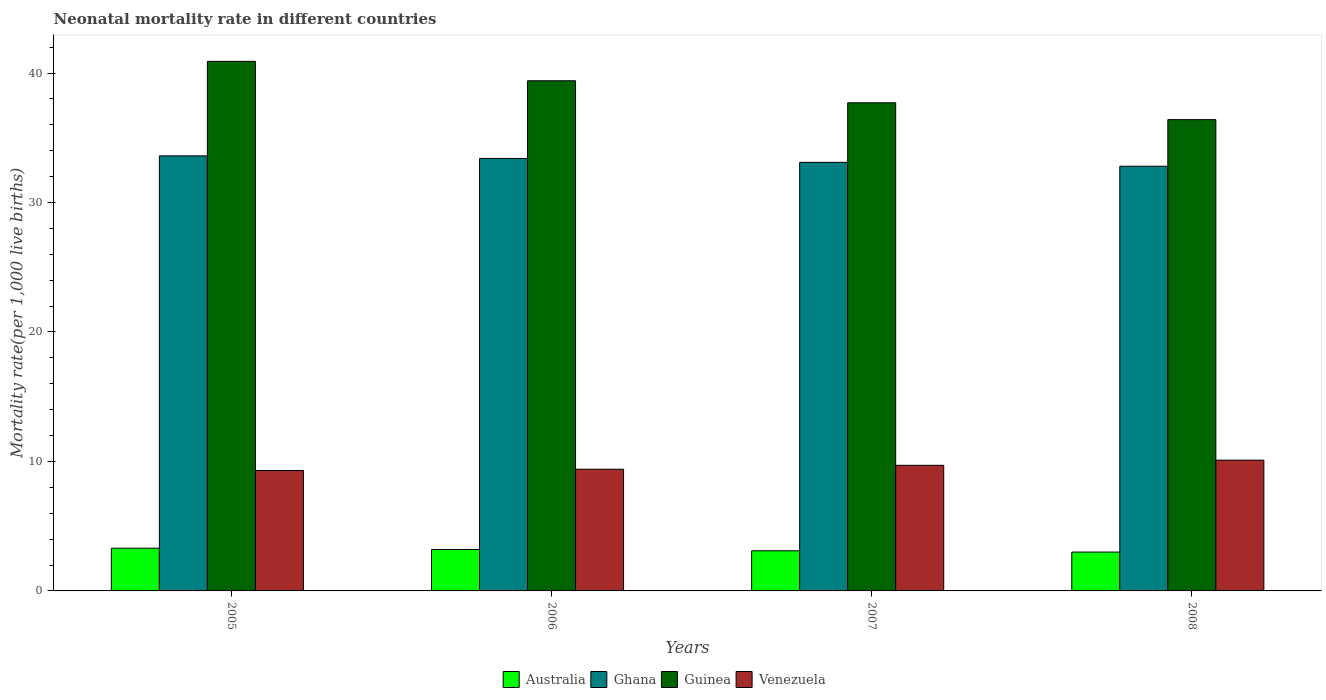Are the number of bars per tick equal to the number of legend labels?
Ensure brevity in your answer.  Yes. Are the number of bars on each tick of the X-axis equal?
Offer a very short reply. Yes. What is the label of the 1st group of bars from the left?
Your response must be concise. 2005. In how many cases, is the number of bars for a given year not equal to the number of legend labels?
Ensure brevity in your answer.  0. Across all years, what is the minimum neonatal mortality rate in Australia?
Make the answer very short. 3. In which year was the neonatal mortality rate in Australia maximum?
Give a very brief answer. 2005. In which year was the neonatal mortality rate in Guinea minimum?
Make the answer very short. 2008. What is the total neonatal mortality rate in Ghana in the graph?
Provide a short and direct response. 132.9. What is the difference between the neonatal mortality rate in Venezuela in 2005 and that in 2006?
Ensure brevity in your answer.  -0.1. What is the difference between the neonatal mortality rate in Ghana in 2008 and the neonatal mortality rate in Guinea in 2006?
Your response must be concise. -6.6. What is the average neonatal mortality rate in Ghana per year?
Give a very brief answer. 33.22. In how many years, is the neonatal mortality rate in Guinea greater than 40?
Keep it short and to the point. 1. What is the ratio of the neonatal mortality rate in Guinea in 2005 to that in 2007?
Your response must be concise. 1.08. Is the neonatal mortality rate in Venezuela in 2006 less than that in 2007?
Offer a very short reply. Yes. What is the difference between the highest and the second highest neonatal mortality rate in Guinea?
Give a very brief answer. 1.5. What is the difference between the highest and the lowest neonatal mortality rate in Venezuela?
Your answer should be compact. 0.8. Is it the case that in every year, the sum of the neonatal mortality rate in Guinea and neonatal mortality rate in Australia is greater than the sum of neonatal mortality rate in Venezuela and neonatal mortality rate in Ghana?
Provide a succinct answer. No. What does the 4th bar from the left in 2006 represents?
Provide a succinct answer. Venezuela. Is it the case that in every year, the sum of the neonatal mortality rate in Australia and neonatal mortality rate in Venezuela is greater than the neonatal mortality rate in Guinea?
Keep it short and to the point. No. Are all the bars in the graph horizontal?
Offer a very short reply. No. What is the difference between two consecutive major ticks on the Y-axis?
Keep it short and to the point. 10. Are the values on the major ticks of Y-axis written in scientific E-notation?
Your answer should be very brief. No. Does the graph contain any zero values?
Offer a terse response. No. Does the graph contain grids?
Provide a short and direct response. No. Where does the legend appear in the graph?
Provide a short and direct response. Bottom center. How many legend labels are there?
Give a very brief answer. 4. How are the legend labels stacked?
Your answer should be very brief. Horizontal. What is the title of the graph?
Make the answer very short. Neonatal mortality rate in different countries. What is the label or title of the X-axis?
Ensure brevity in your answer.  Years. What is the label or title of the Y-axis?
Your answer should be very brief. Mortality rate(per 1,0 live births). What is the Mortality rate(per 1,000 live births) in Australia in 2005?
Your answer should be compact. 3.3. What is the Mortality rate(per 1,000 live births) in Ghana in 2005?
Make the answer very short. 33.6. What is the Mortality rate(per 1,000 live births) in Guinea in 2005?
Your answer should be very brief. 40.9. What is the Mortality rate(per 1,000 live births) of Venezuela in 2005?
Your response must be concise. 9.3. What is the Mortality rate(per 1,000 live births) in Australia in 2006?
Your answer should be compact. 3.2. What is the Mortality rate(per 1,000 live births) in Ghana in 2006?
Provide a short and direct response. 33.4. What is the Mortality rate(per 1,000 live births) of Guinea in 2006?
Offer a terse response. 39.4. What is the Mortality rate(per 1,000 live births) of Ghana in 2007?
Ensure brevity in your answer.  33.1. What is the Mortality rate(per 1,000 live births) in Guinea in 2007?
Give a very brief answer. 37.7. What is the Mortality rate(per 1,000 live births) of Ghana in 2008?
Your response must be concise. 32.8. What is the Mortality rate(per 1,000 live births) of Guinea in 2008?
Your answer should be compact. 36.4. What is the Mortality rate(per 1,000 live births) in Venezuela in 2008?
Your answer should be compact. 10.1. Across all years, what is the maximum Mortality rate(per 1,000 live births) of Ghana?
Keep it short and to the point. 33.6. Across all years, what is the maximum Mortality rate(per 1,000 live births) of Guinea?
Provide a succinct answer. 40.9. Across all years, what is the minimum Mortality rate(per 1,000 live births) of Australia?
Your answer should be compact. 3. Across all years, what is the minimum Mortality rate(per 1,000 live births) of Ghana?
Give a very brief answer. 32.8. Across all years, what is the minimum Mortality rate(per 1,000 live births) in Guinea?
Provide a succinct answer. 36.4. What is the total Mortality rate(per 1,000 live births) of Ghana in the graph?
Make the answer very short. 132.9. What is the total Mortality rate(per 1,000 live births) in Guinea in the graph?
Provide a short and direct response. 154.4. What is the total Mortality rate(per 1,000 live births) in Venezuela in the graph?
Keep it short and to the point. 38.5. What is the difference between the Mortality rate(per 1,000 live births) in Ghana in 2005 and that in 2006?
Offer a terse response. 0.2. What is the difference between the Mortality rate(per 1,000 live births) of Venezuela in 2005 and that in 2006?
Give a very brief answer. -0.1. What is the difference between the Mortality rate(per 1,000 live births) of Venezuela in 2005 and that in 2007?
Keep it short and to the point. -0.4. What is the difference between the Mortality rate(per 1,000 live births) of Ghana in 2005 and that in 2008?
Keep it short and to the point. 0.8. What is the difference between the Mortality rate(per 1,000 live births) in Australia in 2006 and that in 2007?
Provide a succinct answer. 0.1. What is the difference between the Mortality rate(per 1,000 live births) of Guinea in 2006 and that in 2007?
Your answer should be very brief. 1.7. What is the difference between the Mortality rate(per 1,000 live births) in Australia in 2006 and that in 2008?
Your answer should be very brief. 0.2. What is the difference between the Mortality rate(per 1,000 live births) of Guinea in 2006 and that in 2008?
Offer a terse response. 3. What is the difference between the Mortality rate(per 1,000 live births) in Venezuela in 2006 and that in 2008?
Make the answer very short. -0.7. What is the difference between the Mortality rate(per 1,000 live births) in Guinea in 2007 and that in 2008?
Give a very brief answer. 1.3. What is the difference between the Mortality rate(per 1,000 live births) of Australia in 2005 and the Mortality rate(per 1,000 live births) of Ghana in 2006?
Provide a succinct answer. -30.1. What is the difference between the Mortality rate(per 1,000 live births) of Australia in 2005 and the Mortality rate(per 1,000 live births) of Guinea in 2006?
Ensure brevity in your answer.  -36.1. What is the difference between the Mortality rate(per 1,000 live births) in Australia in 2005 and the Mortality rate(per 1,000 live births) in Venezuela in 2006?
Offer a very short reply. -6.1. What is the difference between the Mortality rate(per 1,000 live births) in Ghana in 2005 and the Mortality rate(per 1,000 live births) in Venezuela in 2006?
Make the answer very short. 24.2. What is the difference between the Mortality rate(per 1,000 live births) in Guinea in 2005 and the Mortality rate(per 1,000 live births) in Venezuela in 2006?
Keep it short and to the point. 31.5. What is the difference between the Mortality rate(per 1,000 live births) of Australia in 2005 and the Mortality rate(per 1,000 live births) of Ghana in 2007?
Provide a short and direct response. -29.8. What is the difference between the Mortality rate(per 1,000 live births) of Australia in 2005 and the Mortality rate(per 1,000 live births) of Guinea in 2007?
Offer a very short reply. -34.4. What is the difference between the Mortality rate(per 1,000 live births) of Ghana in 2005 and the Mortality rate(per 1,000 live births) of Venezuela in 2007?
Offer a very short reply. 23.9. What is the difference between the Mortality rate(per 1,000 live births) in Guinea in 2005 and the Mortality rate(per 1,000 live births) in Venezuela in 2007?
Your answer should be very brief. 31.2. What is the difference between the Mortality rate(per 1,000 live births) in Australia in 2005 and the Mortality rate(per 1,000 live births) in Ghana in 2008?
Provide a succinct answer. -29.5. What is the difference between the Mortality rate(per 1,000 live births) of Australia in 2005 and the Mortality rate(per 1,000 live births) of Guinea in 2008?
Your response must be concise. -33.1. What is the difference between the Mortality rate(per 1,000 live births) of Australia in 2005 and the Mortality rate(per 1,000 live births) of Venezuela in 2008?
Offer a terse response. -6.8. What is the difference between the Mortality rate(per 1,000 live births) of Ghana in 2005 and the Mortality rate(per 1,000 live births) of Guinea in 2008?
Your answer should be very brief. -2.8. What is the difference between the Mortality rate(per 1,000 live births) of Ghana in 2005 and the Mortality rate(per 1,000 live births) of Venezuela in 2008?
Keep it short and to the point. 23.5. What is the difference between the Mortality rate(per 1,000 live births) in Guinea in 2005 and the Mortality rate(per 1,000 live births) in Venezuela in 2008?
Offer a terse response. 30.8. What is the difference between the Mortality rate(per 1,000 live births) of Australia in 2006 and the Mortality rate(per 1,000 live births) of Ghana in 2007?
Provide a short and direct response. -29.9. What is the difference between the Mortality rate(per 1,000 live births) in Australia in 2006 and the Mortality rate(per 1,000 live births) in Guinea in 2007?
Keep it short and to the point. -34.5. What is the difference between the Mortality rate(per 1,000 live births) of Australia in 2006 and the Mortality rate(per 1,000 live births) of Venezuela in 2007?
Offer a very short reply. -6.5. What is the difference between the Mortality rate(per 1,000 live births) of Ghana in 2006 and the Mortality rate(per 1,000 live births) of Venezuela in 2007?
Your answer should be compact. 23.7. What is the difference between the Mortality rate(per 1,000 live births) of Guinea in 2006 and the Mortality rate(per 1,000 live births) of Venezuela in 2007?
Offer a terse response. 29.7. What is the difference between the Mortality rate(per 1,000 live births) in Australia in 2006 and the Mortality rate(per 1,000 live births) in Ghana in 2008?
Give a very brief answer. -29.6. What is the difference between the Mortality rate(per 1,000 live births) of Australia in 2006 and the Mortality rate(per 1,000 live births) of Guinea in 2008?
Your response must be concise. -33.2. What is the difference between the Mortality rate(per 1,000 live births) in Ghana in 2006 and the Mortality rate(per 1,000 live births) in Venezuela in 2008?
Your answer should be very brief. 23.3. What is the difference between the Mortality rate(per 1,000 live births) in Guinea in 2006 and the Mortality rate(per 1,000 live births) in Venezuela in 2008?
Provide a short and direct response. 29.3. What is the difference between the Mortality rate(per 1,000 live births) in Australia in 2007 and the Mortality rate(per 1,000 live births) in Ghana in 2008?
Ensure brevity in your answer.  -29.7. What is the difference between the Mortality rate(per 1,000 live births) in Australia in 2007 and the Mortality rate(per 1,000 live births) in Guinea in 2008?
Provide a succinct answer. -33.3. What is the difference between the Mortality rate(per 1,000 live births) of Australia in 2007 and the Mortality rate(per 1,000 live births) of Venezuela in 2008?
Your answer should be very brief. -7. What is the difference between the Mortality rate(per 1,000 live births) in Ghana in 2007 and the Mortality rate(per 1,000 live births) in Guinea in 2008?
Your answer should be compact. -3.3. What is the difference between the Mortality rate(per 1,000 live births) in Guinea in 2007 and the Mortality rate(per 1,000 live births) in Venezuela in 2008?
Your answer should be compact. 27.6. What is the average Mortality rate(per 1,000 live births) of Australia per year?
Your response must be concise. 3.15. What is the average Mortality rate(per 1,000 live births) in Ghana per year?
Make the answer very short. 33.23. What is the average Mortality rate(per 1,000 live births) in Guinea per year?
Offer a very short reply. 38.6. What is the average Mortality rate(per 1,000 live births) in Venezuela per year?
Make the answer very short. 9.62. In the year 2005, what is the difference between the Mortality rate(per 1,000 live births) in Australia and Mortality rate(per 1,000 live births) in Ghana?
Offer a terse response. -30.3. In the year 2005, what is the difference between the Mortality rate(per 1,000 live births) of Australia and Mortality rate(per 1,000 live births) of Guinea?
Provide a succinct answer. -37.6. In the year 2005, what is the difference between the Mortality rate(per 1,000 live births) of Ghana and Mortality rate(per 1,000 live births) of Venezuela?
Make the answer very short. 24.3. In the year 2005, what is the difference between the Mortality rate(per 1,000 live births) of Guinea and Mortality rate(per 1,000 live births) of Venezuela?
Your response must be concise. 31.6. In the year 2006, what is the difference between the Mortality rate(per 1,000 live births) in Australia and Mortality rate(per 1,000 live births) in Ghana?
Your response must be concise. -30.2. In the year 2006, what is the difference between the Mortality rate(per 1,000 live births) in Australia and Mortality rate(per 1,000 live births) in Guinea?
Your answer should be compact. -36.2. In the year 2006, what is the difference between the Mortality rate(per 1,000 live births) in Ghana and Mortality rate(per 1,000 live births) in Guinea?
Make the answer very short. -6. In the year 2006, what is the difference between the Mortality rate(per 1,000 live births) of Ghana and Mortality rate(per 1,000 live births) of Venezuela?
Keep it short and to the point. 24. In the year 2006, what is the difference between the Mortality rate(per 1,000 live births) of Guinea and Mortality rate(per 1,000 live births) of Venezuela?
Provide a short and direct response. 30. In the year 2007, what is the difference between the Mortality rate(per 1,000 live births) of Australia and Mortality rate(per 1,000 live births) of Ghana?
Provide a short and direct response. -30. In the year 2007, what is the difference between the Mortality rate(per 1,000 live births) in Australia and Mortality rate(per 1,000 live births) in Guinea?
Your answer should be compact. -34.6. In the year 2007, what is the difference between the Mortality rate(per 1,000 live births) of Ghana and Mortality rate(per 1,000 live births) of Guinea?
Offer a terse response. -4.6. In the year 2007, what is the difference between the Mortality rate(per 1,000 live births) in Ghana and Mortality rate(per 1,000 live births) in Venezuela?
Your answer should be very brief. 23.4. In the year 2008, what is the difference between the Mortality rate(per 1,000 live births) of Australia and Mortality rate(per 1,000 live births) of Ghana?
Offer a terse response. -29.8. In the year 2008, what is the difference between the Mortality rate(per 1,000 live births) in Australia and Mortality rate(per 1,000 live births) in Guinea?
Offer a very short reply. -33.4. In the year 2008, what is the difference between the Mortality rate(per 1,000 live births) in Australia and Mortality rate(per 1,000 live births) in Venezuela?
Your response must be concise. -7.1. In the year 2008, what is the difference between the Mortality rate(per 1,000 live births) in Ghana and Mortality rate(per 1,000 live births) in Venezuela?
Offer a terse response. 22.7. In the year 2008, what is the difference between the Mortality rate(per 1,000 live births) of Guinea and Mortality rate(per 1,000 live births) of Venezuela?
Provide a short and direct response. 26.3. What is the ratio of the Mortality rate(per 1,000 live births) in Australia in 2005 to that in 2006?
Provide a short and direct response. 1.03. What is the ratio of the Mortality rate(per 1,000 live births) of Ghana in 2005 to that in 2006?
Provide a short and direct response. 1.01. What is the ratio of the Mortality rate(per 1,000 live births) of Guinea in 2005 to that in 2006?
Keep it short and to the point. 1.04. What is the ratio of the Mortality rate(per 1,000 live births) in Venezuela in 2005 to that in 2006?
Offer a very short reply. 0.99. What is the ratio of the Mortality rate(per 1,000 live births) in Australia in 2005 to that in 2007?
Provide a short and direct response. 1.06. What is the ratio of the Mortality rate(per 1,000 live births) of Ghana in 2005 to that in 2007?
Give a very brief answer. 1.02. What is the ratio of the Mortality rate(per 1,000 live births) of Guinea in 2005 to that in 2007?
Offer a very short reply. 1.08. What is the ratio of the Mortality rate(per 1,000 live births) in Venezuela in 2005 to that in 2007?
Keep it short and to the point. 0.96. What is the ratio of the Mortality rate(per 1,000 live births) in Ghana in 2005 to that in 2008?
Make the answer very short. 1.02. What is the ratio of the Mortality rate(per 1,000 live births) in Guinea in 2005 to that in 2008?
Keep it short and to the point. 1.12. What is the ratio of the Mortality rate(per 1,000 live births) of Venezuela in 2005 to that in 2008?
Your answer should be very brief. 0.92. What is the ratio of the Mortality rate(per 1,000 live births) in Australia in 2006 to that in 2007?
Make the answer very short. 1.03. What is the ratio of the Mortality rate(per 1,000 live births) of Ghana in 2006 to that in 2007?
Your answer should be very brief. 1.01. What is the ratio of the Mortality rate(per 1,000 live births) in Guinea in 2006 to that in 2007?
Your response must be concise. 1.05. What is the ratio of the Mortality rate(per 1,000 live births) in Venezuela in 2006 to that in 2007?
Your answer should be compact. 0.97. What is the ratio of the Mortality rate(per 1,000 live births) of Australia in 2006 to that in 2008?
Provide a short and direct response. 1.07. What is the ratio of the Mortality rate(per 1,000 live births) in Ghana in 2006 to that in 2008?
Offer a very short reply. 1.02. What is the ratio of the Mortality rate(per 1,000 live births) of Guinea in 2006 to that in 2008?
Give a very brief answer. 1.08. What is the ratio of the Mortality rate(per 1,000 live births) of Venezuela in 2006 to that in 2008?
Offer a very short reply. 0.93. What is the ratio of the Mortality rate(per 1,000 live births) of Australia in 2007 to that in 2008?
Provide a short and direct response. 1.03. What is the ratio of the Mortality rate(per 1,000 live births) of Ghana in 2007 to that in 2008?
Provide a succinct answer. 1.01. What is the ratio of the Mortality rate(per 1,000 live births) of Guinea in 2007 to that in 2008?
Your answer should be very brief. 1.04. What is the ratio of the Mortality rate(per 1,000 live births) in Venezuela in 2007 to that in 2008?
Offer a very short reply. 0.96. What is the difference between the highest and the second highest Mortality rate(per 1,000 live births) of Australia?
Your answer should be compact. 0.1. What is the difference between the highest and the second highest Mortality rate(per 1,000 live births) in Ghana?
Provide a short and direct response. 0.2. What is the difference between the highest and the second highest Mortality rate(per 1,000 live births) in Venezuela?
Provide a short and direct response. 0.4. What is the difference between the highest and the lowest Mortality rate(per 1,000 live births) of Australia?
Keep it short and to the point. 0.3. 